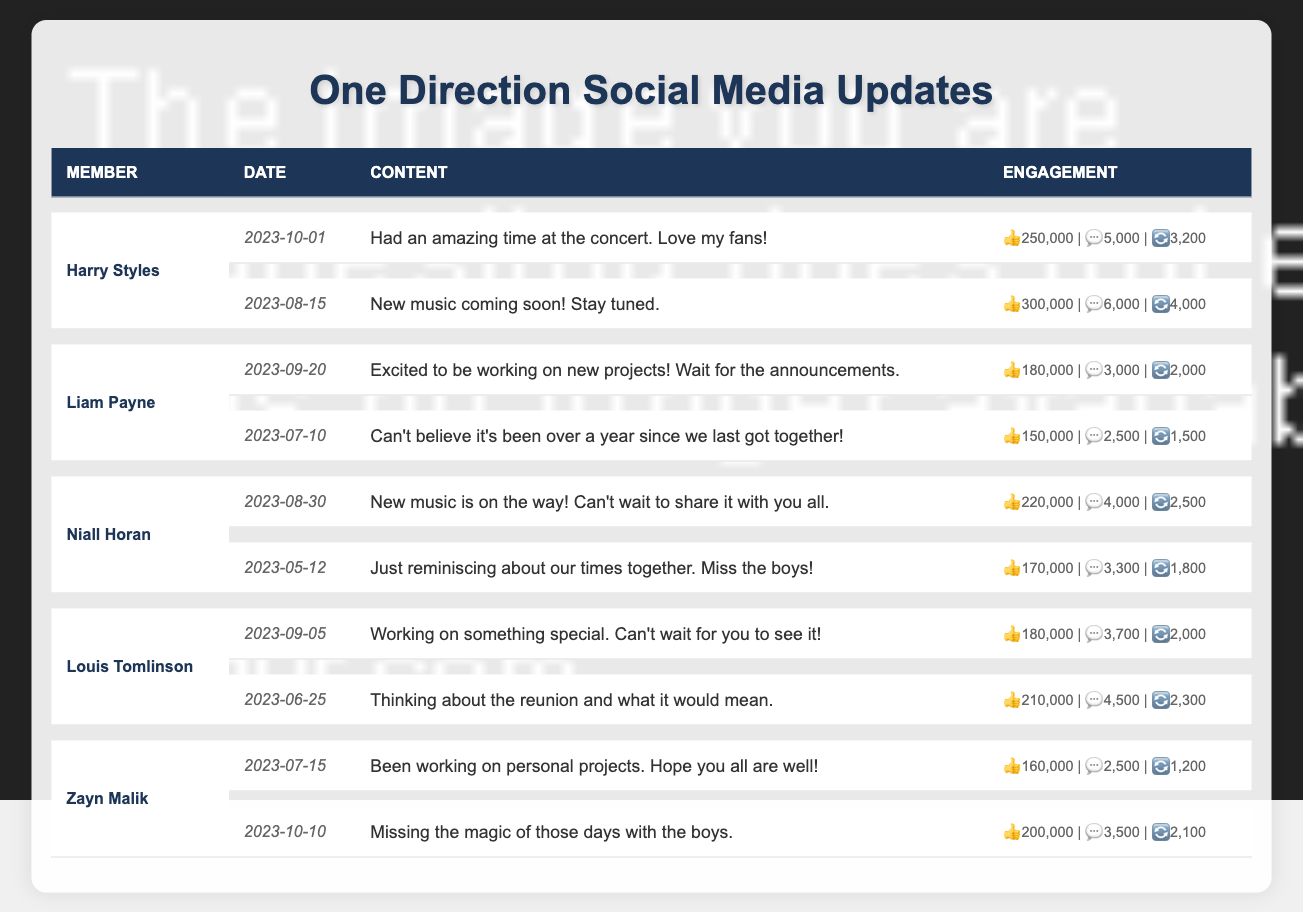What was the date of Harry Styles' most recent post? Harry Styles' most recent post is dated October 1, 2023. This is determined by looking at the table and identifying the latest date for his posts.
Answer: October 1, 2023 Which member had the highest engagement in their most recent post? Analyzing the engagement metrics of the most recent posts, Harry Styles received 250,000 likes, 5,000 comments, and 3,200 shares. Comparing these metrics with others, he has the highest overall engagement for his latest post.
Answer: Harry Styles What is the total number of likes received by Niall Horan's two recent posts? For Niall Horan's recent posts, the likes are 220,000 (August 30) and 170,000 (May 12). Summing these gives 220,000 + 170,000 = 390,000 likes.
Answer: 390,000 How many comments did Louis Tomlinson receive in total for his last two posts? Louis Tomlinson received 3,700 comments for his September 5 post and 4,500 comments for his June 25 post. Adding these gives 3,700 + 4,500 = 8,200 comments.
Answer: 8,200 Did Zayn Malik's post on October 10 receive more shares than his post on July 15? Zayn Malik's post on October 10 received 2,100 shares, while his post on July 15 received 1,200 shares. Comparing these numbers shows that the October post received more shares.
Answer: Yes What is the average number of likes received across all recent posts from Liam Payne? Liam Payne's posts received 180,000 likes (September 20) and 150,000 likes (July 10). To find the average, sum these likes (180,000 + 150,000 = 330,000) and divide by the number of posts (2): 330,000 / 2 = 165,000.
Answer: 165,000 Who had the highest number of shares in any of their posts? Looking at the shares, Niall Horan's post on August 30 received 2,500 shares, while Harry Styles' latest post received 3,200. Comparing all posts reveals that Harry Styles had the highest shares.
Answer: Harry Styles Which member expressed feelings of nostalgia about their time together with the group? Niall Horan mentioned missing the times with the boys in his May 12 post, and Zayn Malik also expressed missing the magic of those days in October 10. Therefore, both exhibited nostalgia.
Answer: Niall Horan and Zayn Malik How many total engagements (likes + comments + shares) did Louis Tomlinson receive for both of his posts? For Louis Tomlinson, the total engagements for his posts are calculated as follows: 180,000 likes + 3,700 comments + 2,000 shares = 185,700 for September 5, and for June 25, 210,000 likes + 4,500 comments + 2,300 shares = 216,800. Adding them gives 185,700 + 216,800 = 402,500 total engagements.
Answer: 402,500 Which member had a post mentioning new music? Harry Styles, Niall Horan, and Liam Payne all mentioned new music in their recent posts. Harry's post on August 15 stated, "New music coming soon," and Niall's on August 30 stated, "New music is on the way!"
Answer: Harry Styles and Niall Horan What was the total number of comments made on all posts by Zayn Malik? Zayn Malik received 2,500 comments for his July 15 post and 3,500 comments for his October 10 post. Summing these gives 2,500 + 3,500 = 6,000 total comments.
Answer: 6,000 